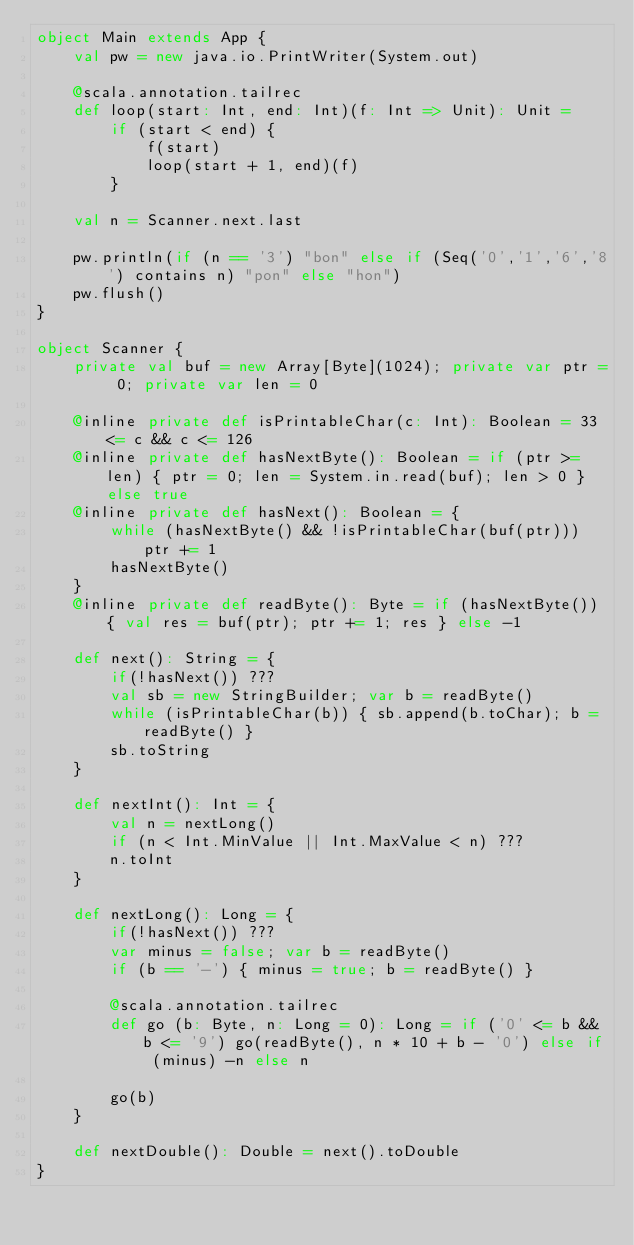Convert code to text. <code><loc_0><loc_0><loc_500><loc_500><_Scala_>object Main extends App {
	val pw = new java.io.PrintWriter(System.out)

	@scala.annotation.tailrec
	def loop(start: Int, end: Int)(f: Int => Unit): Unit =
		if (start < end) {
			f(start)
			loop(start + 1, end)(f)
		}

	val n = Scanner.next.last

	pw.println(if (n == '3') "bon" else if (Seq('0','1','6','8') contains n) "pon" else "hon")
	pw.flush()
}

object Scanner {
	private val buf = new Array[Byte](1024); private var ptr = 0; private var len = 0

	@inline private def isPrintableChar(c: Int): Boolean = 33 <= c && c <= 126
	@inline private def hasNextByte(): Boolean = if (ptr >= len) { ptr = 0; len = System.in.read(buf); len > 0 } else true
	@inline private def hasNext(): Boolean = {
		while (hasNextByte() && !isPrintableChar(buf(ptr))) ptr += 1
		hasNextByte()
	}
	@inline private def readByte(): Byte = if (hasNextByte()) { val res = buf(ptr); ptr += 1; res } else -1

	def next(): String = {
		if(!hasNext()) ???
		val sb = new StringBuilder; var b = readByte()
		while (isPrintableChar(b)) { sb.append(b.toChar); b = readByte() }
		sb.toString
	}

	def nextInt(): Int = {
		val n = nextLong()
		if (n < Int.MinValue || Int.MaxValue < n) ???
		n.toInt
	}

	def nextLong(): Long = {
		if(!hasNext()) ???
		var minus = false; var b = readByte()
		if (b == '-') { minus = true; b = readByte() }

		@scala.annotation.tailrec
		def go (b: Byte, n: Long = 0): Long = if ('0' <= b && b <= '9') go(readByte(), n * 10 + b - '0') else if (minus) -n else n

		go(b)
	}

	def nextDouble(): Double = next().toDouble
}
</code> 